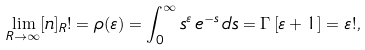<formula> <loc_0><loc_0><loc_500><loc_500>\lim _ { R \rightarrow \infty } [ n ] _ { R } ! = \rho ( \varepsilon ) = \int _ { 0 } ^ { \infty } s ^ { \varepsilon } \, e ^ { - s } \, d s = \Gamma \left [ \varepsilon + 1 \right ] = \varepsilon ! ,</formula> 